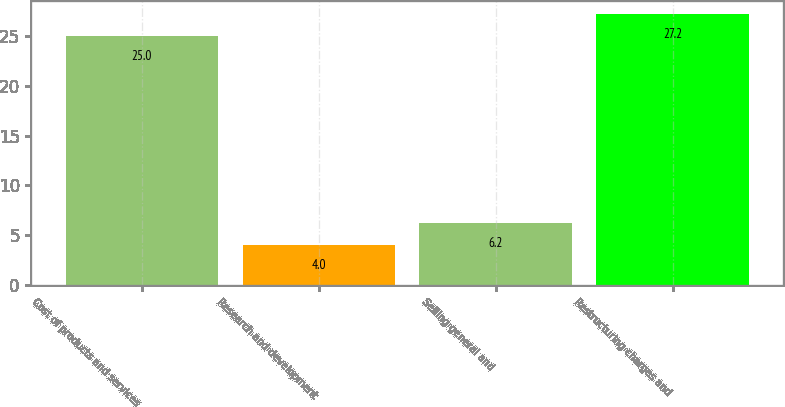Convert chart to OTSL. <chart><loc_0><loc_0><loc_500><loc_500><bar_chart><fcel>Cost of products and services<fcel>Research and development<fcel>Selling general and<fcel>Restructuring charges and<nl><fcel>25<fcel>4<fcel>6.2<fcel>27.2<nl></chart> 